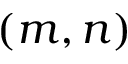<formula> <loc_0><loc_0><loc_500><loc_500>( m , n )</formula> 